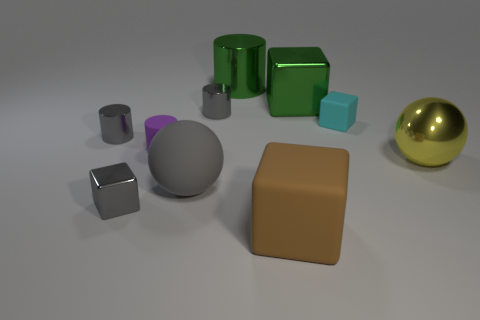How many tiny gray cylinders are behind the cyan rubber thing?
Provide a succinct answer. 1. Do the big matte sphere and the large metallic block have the same color?
Give a very brief answer. No. What number of other big matte balls are the same color as the rubber ball?
Provide a succinct answer. 0. Are there more gray shiny blocks than shiny things?
Make the answer very short. No. What is the size of the thing that is behind the yellow object and to the right of the large green metal cube?
Your answer should be compact. Small. Are the ball that is on the left side of the tiny cyan thing and the gray thing behind the tiny matte cube made of the same material?
Keep it short and to the point. No. There is another rubber thing that is the same size as the cyan thing; what is its shape?
Give a very brief answer. Cylinder. Is the number of metal blocks less than the number of cyan objects?
Provide a short and direct response. No. There is a tiny gray shiny thing that is in front of the tiny purple rubber thing; are there any tiny gray metallic objects that are on the right side of it?
Give a very brief answer. Yes. Is there a purple matte cylinder behind the rubber cube on the right side of the metallic block that is right of the brown thing?
Offer a terse response. No. 